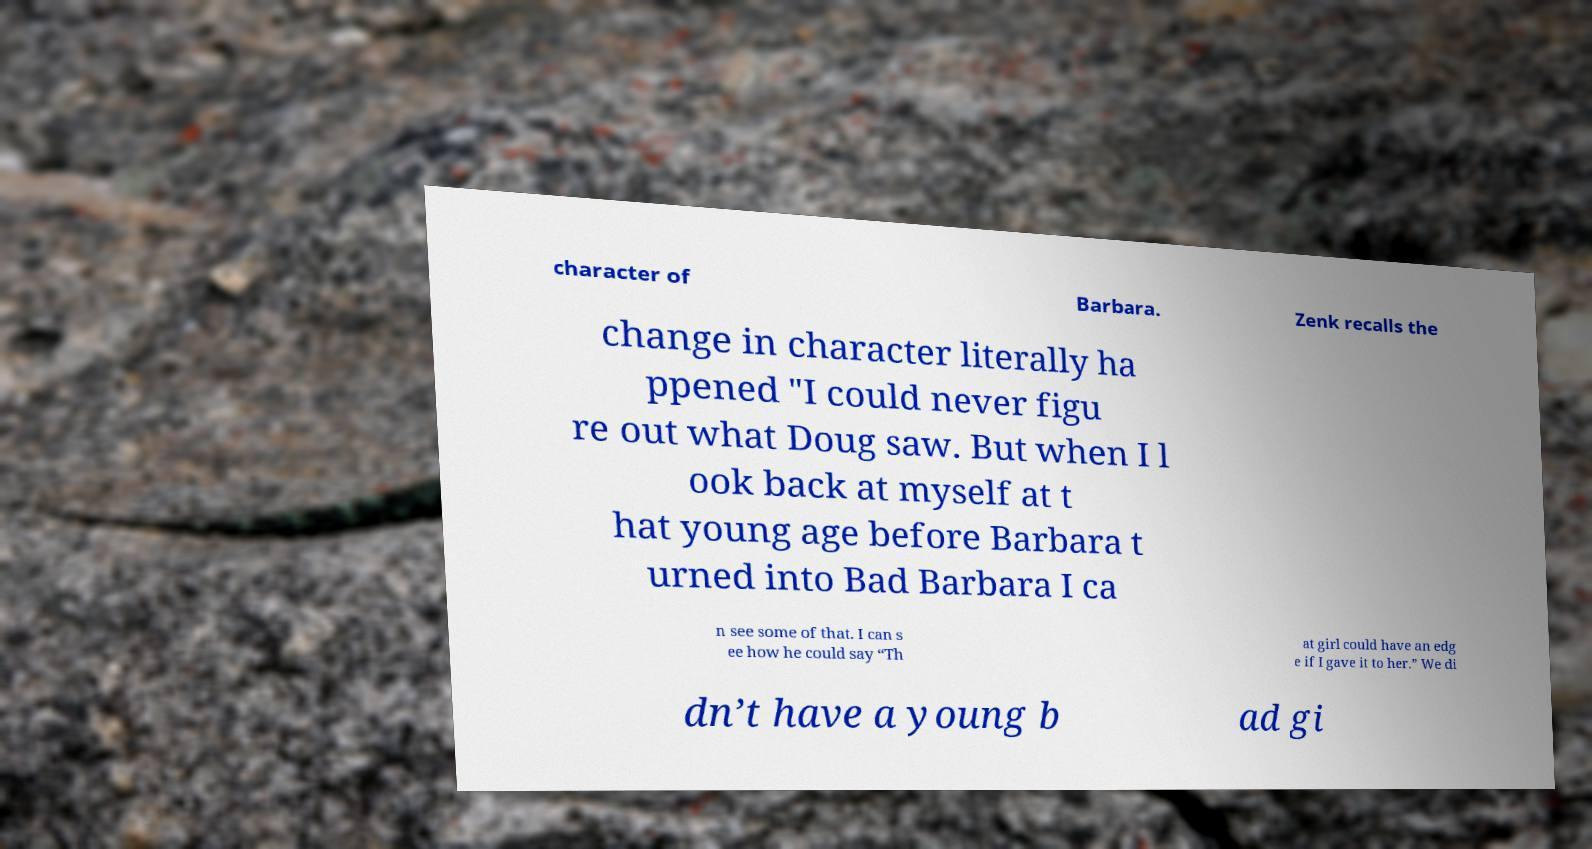Could you extract and type out the text from this image? character of Barbara. Zenk recalls the change in character literally ha ppened "I could never figu re out what Doug saw. But when I l ook back at myself at t hat young age before Barbara t urned into Bad Barbara I ca n see some of that. I can s ee how he could say “Th at girl could have an edg e if I gave it to her.” We di dn’t have a young b ad gi 